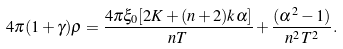<formula> <loc_0><loc_0><loc_500><loc_500>4 \pi ( 1 + \gamma ) \rho = \frac { 4 \pi \xi _ { 0 } [ 2 K + ( n + 2 ) k \alpha ] } { n T } + \frac { ( \alpha ^ { 2 } - 1 ) } { n ^ { 2 } T ^ { 2 } } .</formula> 